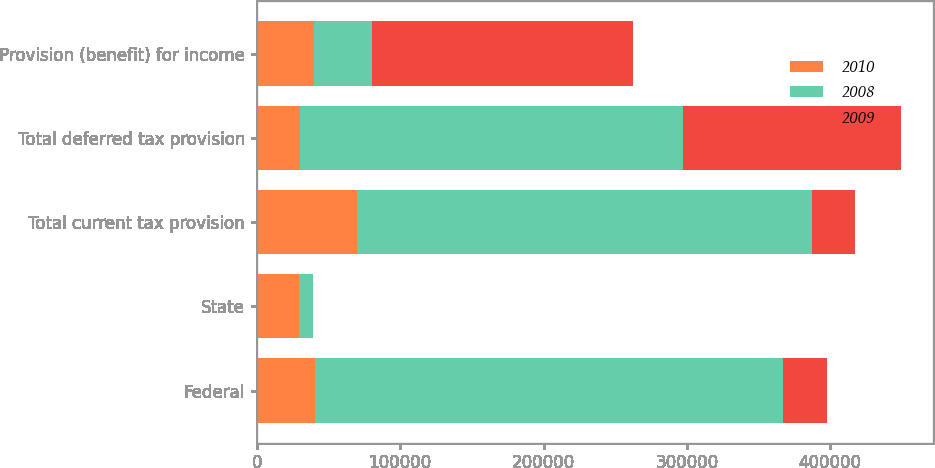Convert chart to OTSL. <chart><loc_0><loc_0><loc_500><loc_500><stacked_bar_chart><ecel><fcel>Federal<fcel>State<fcel>Total current tax provision<fcel>Total deferred tax provision<fcel>Provision (benefit) for income<nl><fcel>2010<fcel>40675<fcel>29539<fcel>70214<fcel>30250<fcel>39964<nl><fcel>2008<fcel>326659<fcel>9860<fcel>316799<fcel>267205<fcel>40319.5<nl><fcel>2009<fcel>30164<fcel>102<fcel>30266<fcel>151936<fcel>182202<nl></chart> 